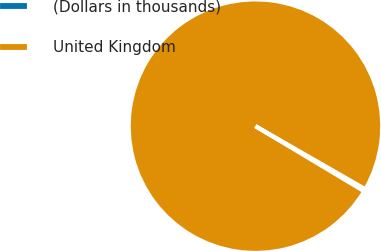Convert chart to OTSL. <chart><loc_0><loc_0><loc_500><loc_500><pie_chart><fcel>(Dollars in thousands)<fcel>United Kingdom<nl><fcel>0.3%<fcel>99.7%<nl></chart> 